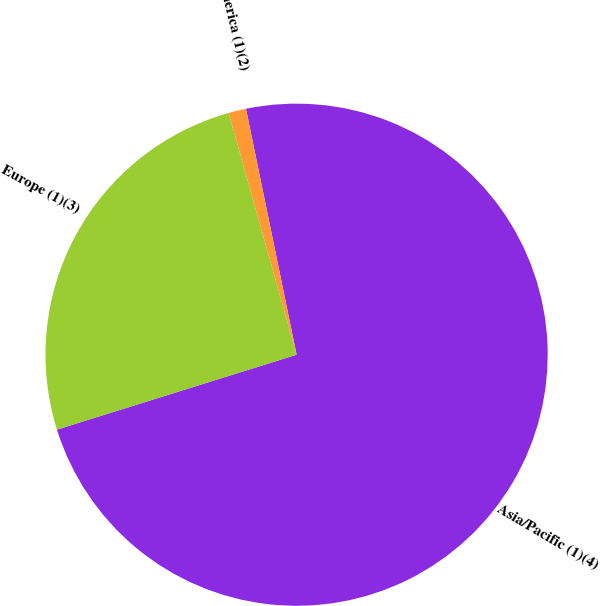Convert chart. <chart><loc_0><loc_0><loc_500><loc_500><pie_chart><fcel>Asia/Pacific (1)(4)<fcel>Europe (1)(3)<fcel>North America (1)(2)<nl><fcel>73.41%<fcel>25.46%<fcel>1.13%<nl></chart> 